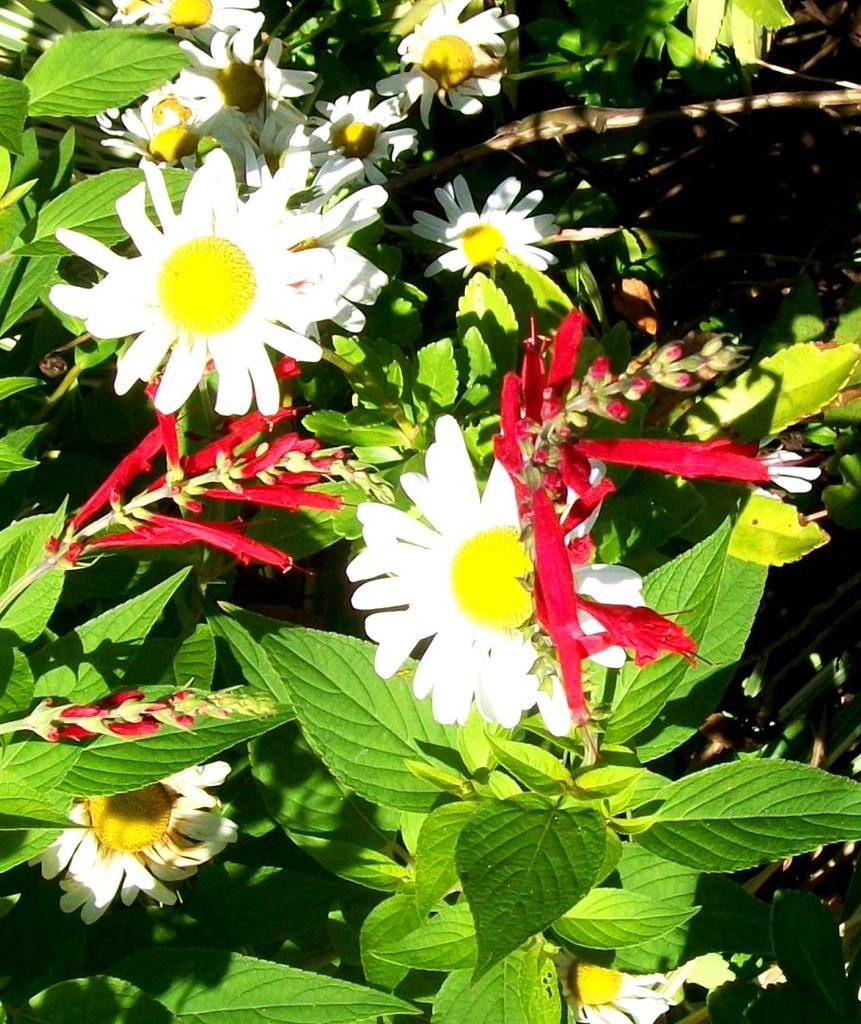What types of living organisms can be seen in the image? Plants and flowers are visible in the image. What stage of growth can be observed in the image? There are buds in the image, indicating that some of the plants are in the early stages of growth. How does the mass of the flowers affect the sneeze of the person in the image? There is no person present in the image, and therefore no sneeze to be affected by the mass of the flowers. 